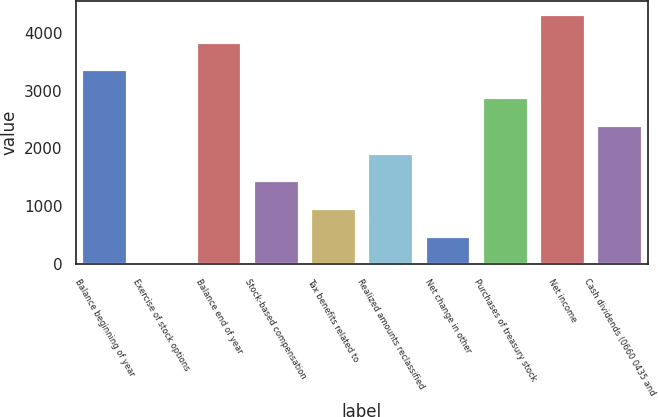Convert chart to OTSL. <chart><loc_0><loc_0><loc_500><loc_500><bar_chart><fcel>Balance beginning of year<fcel>Exercise of stock options<fcel>Balance end of year<fcel>Stock-based compensation<fcel>Tax benefits related to<fcel>Realized amounts reclassified<fcel>Net change in other<fcel>Purchases of treasury stock<fcel>Net income<fcel>Cash dividends (0660 0435 and<nl><fcel>3367.8<fcel>5<fcel>3848.2<fcel>1446.2<fcel>965.8<fcel>1926.6<fcel>485.4<fcel>2887.4<fcel>4328.6<fcel>2407<nl></chart> 